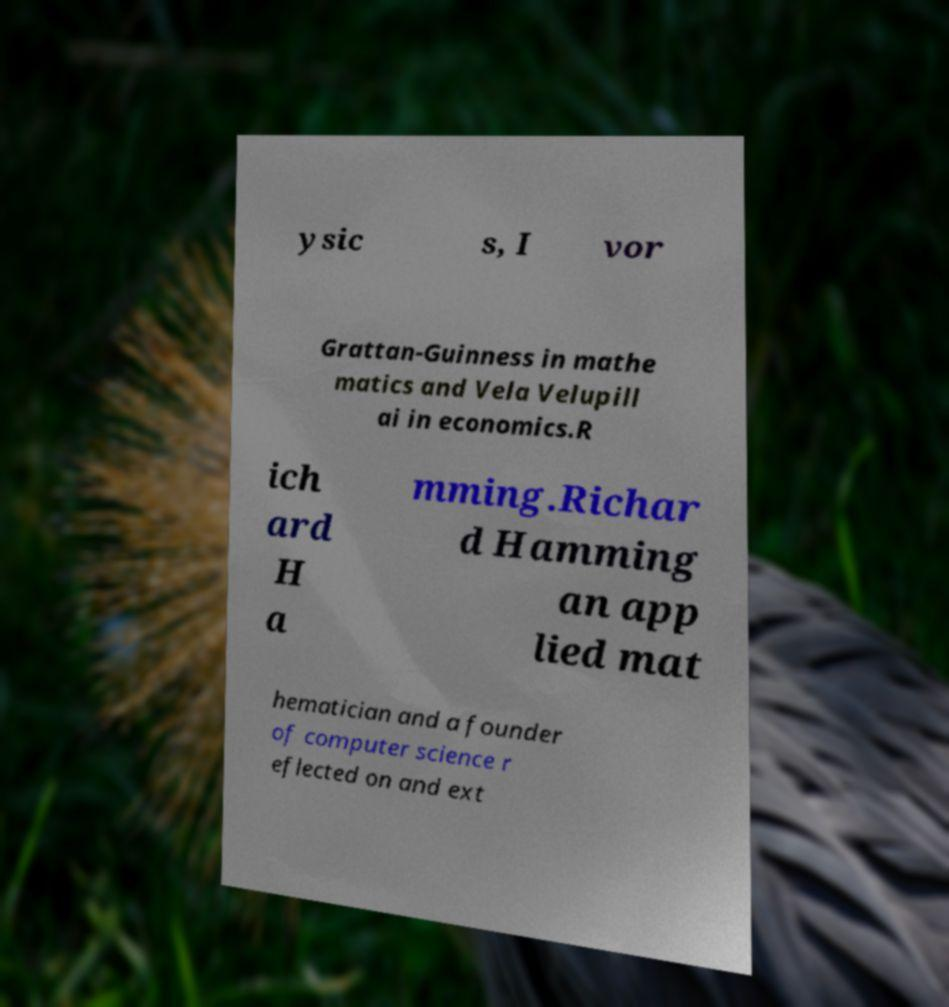I need the written content from this picture converted into text. Can you do that? ysic s, I vor Grattan-Guinness in mathe matics and Vela Velupill ai in economics.R ich ard H a mming.Richar d Hamming an app lied mat hematician and a founder of computer science r eflected on and ext 